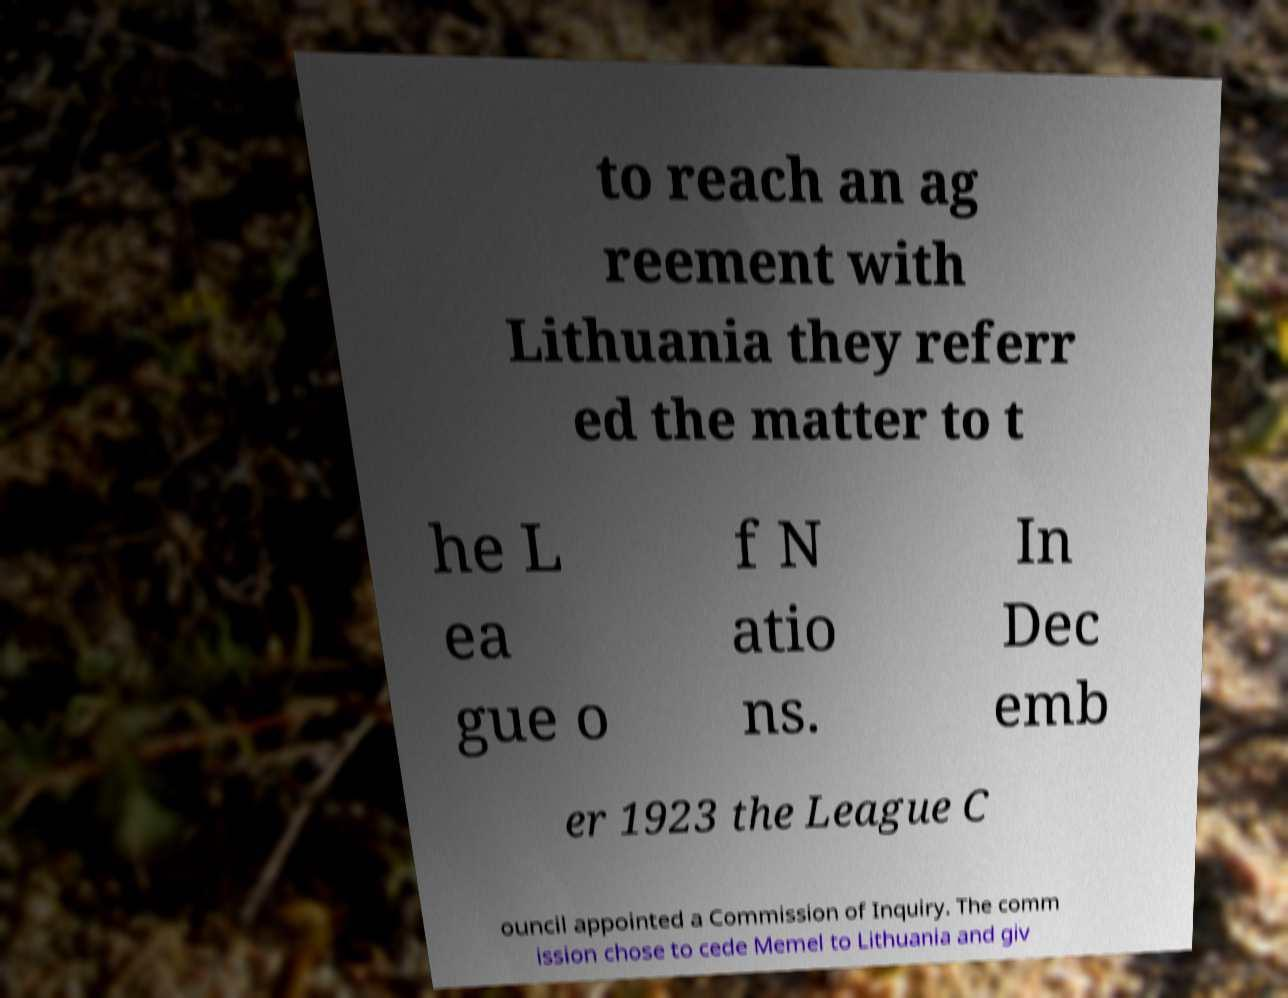Please read and relay the text visible in this image. What does it say? to reach an ag reement with Lithuania they referr ed the matter to t he L ea gue o f N atio ns. In Dec emb er 1923 the League C ouncil appointed a Commission of Inquiry. The comm ission chose to cede Memel to Lithuania and giv 